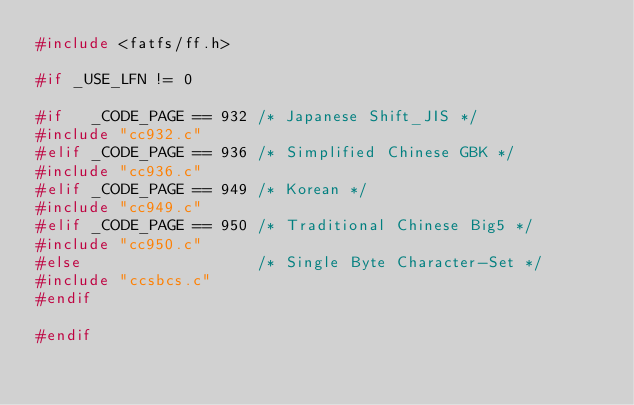Convert code to text. <code><loc_0><loc_0><loc_500><loc_500><_C_>#include <fatfs/ff.h>

#if _USE_LFN != 0

#if   _CODE_PAGE == 932	/* Japanese Shift_JIS */
#include "cc932.c"
#elif _CODE_PAGE == 936	/* Simplified Chinese GBK */
#include "cc936.c"
#elif _CODE_PAGE == 949	/* Korean */
#include "cc949.c"
#elif _CODE_PAGE == 950	/* Traditional Chinese Big5 */
#include "cc950.c"
#else					/* Single Byte Character-Set */
#include "ccsbcs.c"
#endif

#endif
</code> 